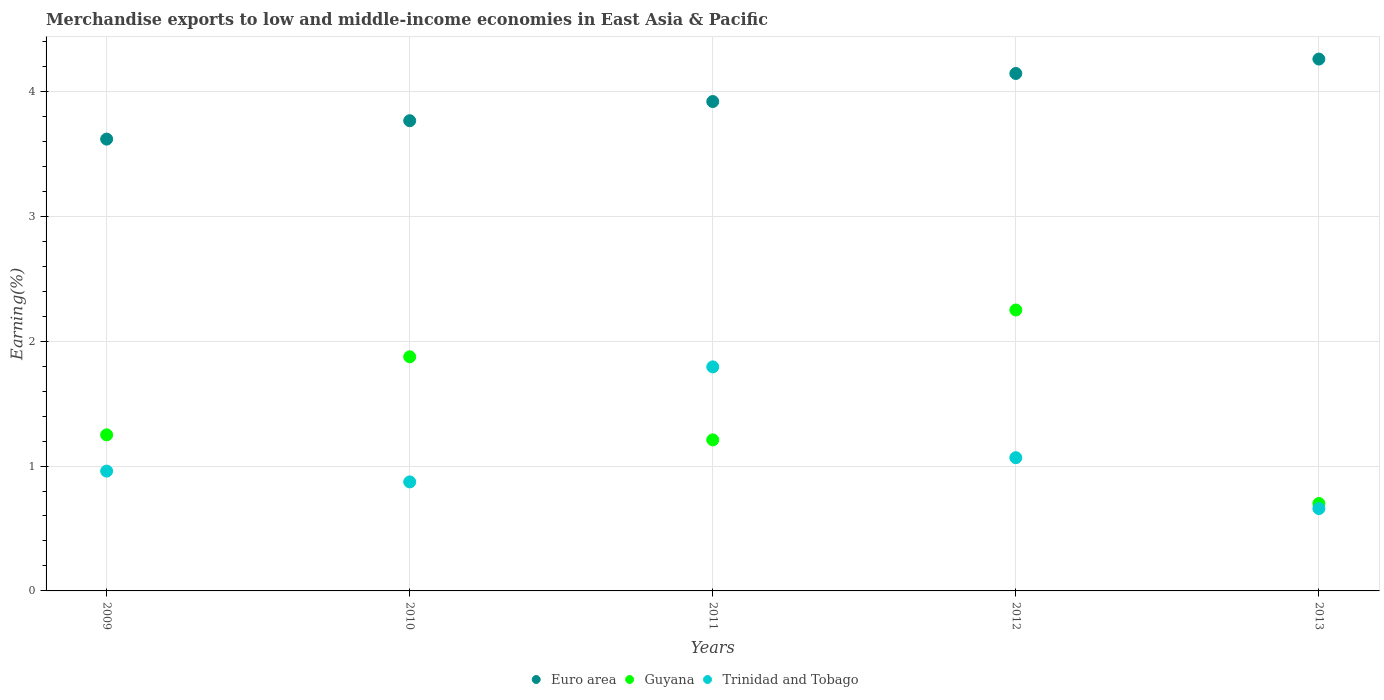Is the number of dotlines equal to the number of legend labels?
Your answer should be very brief. Yes. What is the percentage of amount earned from merchandise exports in Trinidad and Tobago in 2013?
Ensure brevity in your answer.  0.66. Across all years, what is the maximum percentage of amount earned from merchandise exports in Trinidad and Tobago?
Make the answer very short. 1.79. Across all years, what is the minimum percentage of amount earned from merchandise exports in Guyana?
Give a very brief answer. 0.7. What is the total percentage of amount earned from merchandise exports in Trinidad and Tobago in the graph?
Your answer should be compact. 5.35. What is the difference between the percentage of amount earned from merchandise exports in Trinidad and Tobago in 2011 and that in 2013?
Your answer should be compact. 1.13. What is the difference between the percentage of amount earned from merchandise exports in Trinidad and Tobago in 2013 and the percentage of amount earned from merchandise exports in Euro area in 2010?
Provide a succinct answer. -3.11. What is the average percentage of amount earned from merchandise exports in Guyana per year?
Your response must be concise. 1.46. In the year 2013, what is the difference between the percentage of amount earned from merchandise exports in Euro area and percentage of amount earned from merchandise exports in Guyana?
Provide a short and direct response. 3.56. What is the ratio of the percentage of amount earned from merchandise exports in Trinidad and Tobago in 2012 to that in 2013?
Provide a short and direct response. 1.62. Is the difference between the percentage of amount earned from merchandise exports in Euro area in 2009 and 2012 greater than the difference between the percentage of amount earned from merchandise exports in Guyana in 2009 and 2012?
Provide a succinct answer. Yes. What is the difference between the highest and the second highest percentage of amount earned from merchandise exports in Guyana?
Keep it short and to the point. 0.37. What is the difference between the highest and the lowest percentage of amount earned from merchandise exports in Guyana?
Offer a terse response. 1.55. In how many years, is the percentage of amount earned from merchandise exports in Trinidad and Tobago greater than the average percentage of amount earned from merchandise exports in Trinidad and Tobago taken over all years?
Keep it short and to the point. 1. Is it the case that in every year, the sum of the percentage of amount earned from merchandise exports in Trinidad and Tobago and percentage of amount earned from merchandise exports in Guyana  is greater than the percentage of amount earned from merchandise exports in Euro area?
Provide a succinct answer. No. Is the percentage of amount earned from merchandise exports in Trinidad and Tobago strictly greater than the percentage of amount earned from merchandise exports in Guyana over the years?
Provide a succinct answer. No. How many years are there in the graph?
Offer a very short reply. 5. What is the difference between two consecutive major ticks on the Y-axis?
Offer a very short reply. 1. Does the graph contain any zero values?
Your answer should be compact. No. Does the graph contain grids?
Provide a short and direct response. Yes. What is the title of the graph?
Your answer should be compact. Merchandise exports to low and middle-income economies in East Asia & Pacific. What is the label or title of the X-axis?
Your answer should be very brief. Years. What is the label or title of the Y-axis?
Keep it short and to the point. Earning(%). What is the Earning(%) of Euro area in 2009?
Give a very brief answer. 3.62. What is the Earning(%) in Guyana in 2009?
Keep it short and to the point. 1.25. What is the Earning(%) of Trinidad and Tobago in 2009?
Provide a short and direct response. 0.96. What is the Earning(%) of Euro area in 2010?
Give a very brief answer. 3.76. What is the Earning(%) in Guyana in 2010?
Provide a short and direct response. 1.87. What is the Earning(%) in Trinidad and Tobago in 2010?
Offer a very short reply. 0.87. What is the Earning(%) in Euro area in 2011?
Offer a terse response. 3.92. What is the Earning(%) of Guyana in 2011?
Keep it short and to the point. 1.21. What is the Earning(%) of Trinidad and Tobago in 2011?
Offer a terse response. 1.79. What is the Earning(%) in Euro area in 2012?
Offer a very short reply. 4.14. What is the Earning(%) of Guyana in 2012?
Keep it short and to the point. 2.25. What is the Earning(%) of Trinidad and Tobago in 2012?
Give a very brief answer. 1.07. What is the Earning(%) of Euro area in 2013?
Make the answer very short. 4.26. What is the Earning(%) of Guyana in 2013?
Your response must be concise. 0.7. What is the Earning(%) of Trinidad and Tobago in 2013?
Your answer should be compact. 0.66. Across all years, what is the maximum Earning(%) of Euro area?
Your answer should be very brief. 4.26. Across all years, what is the maximum Earning(%) in Guyana?
Ensure brevity in your answer.  2.25. Across all years, what is the maximum Earning(%) in Trinidad and Tobago?
Provide a short and direct response. 1.79. Across all years, what is the minimum Earning(%) of Euro area?
Provide a succinct answer. 3.62. Across all years, what is the minimum Earning(%) in Guyana?
Provide a succinct answer. 0.7. Across all years, what is the minimum Earning(%) of Trinidad and Tobago?
Provide a succinct answer. 0.66. What is the total Earning(%) of Euro area in the graph?
Offer a terse response. 19.7. What is the total Earning(%) in Guyana in the graph?
Ensure brevity in your answer.  7.28. What is the total Earning(%) of Trinidad and Tobago in the graph?
Your response must be concise. 5.35. What is the difference between the Earning(%) of Euro area in 2009 and that in 2010?
Offer a very short reply. -0.15. What is the difference between the Earning(%) of Guyana in 2009 and that in 2010?
Your response must be concise. -0.62. What is the difference between the Earning(%) in Trinidad and Tobago in 2009 and that in 2010?
Give a very brief answer. 0.09. What is the difference between the Earning(%) of Euro area in 2009 and that in 2011?
Provide a short and direct response. -0.3. What is the difference between the Earning(%) in Guyana in 2009 and that in 2011?
Make the answer very short. 0.04. What is the difference between the Earning(%) in Trinidad and Tobago in 2009 and that in 2011?
Provide a succinct answer. -0.83. What is the difference between the Earning(%) of Euro area in 2009 and that in 2012?
Your response must be concise. -0.53. What is the difference between the Earning(%) in Guyana in 2009 and that in 2012?
Keep it short and to the point. -1. What is the difference between the Earning(%) in Trinidad and Tobago in 2009 and that in 2012?
Keep it short and to the point. -0.11. What is the difference between the Earning(%) in Euro area in 2009 and that in 2013?
Make the answer very short. -0.64. What is the difference between the Earning(%) in Guyana in 2009 and that in 2013?
Give a very brief answer. 0.55. What is the difference between the Earning(%) in Euro area in 2010 and that in 2011?
Ensure brevity in your answer.  -0.15. What is the difference between the Earning(%) in Guyana in 2010 and that in 2011?
Offer a terse response. 0.67. What is the difference between the Earning(%) in Trinidad and Tobago in 2010 and that in 2011?
Provide a succinct answer. -0.92. What is the difference between the Earning(%) in Euro area in 2010 and that in 2012?
Offer a terse response. -0.38. What is the difference between the Earning(%) of Guyana in 2010 and that in 2012?
Keep it short and to the point. -0.37. What is the difference between the Earning(%) of Trinidad and Tobago in 2010 and that in 2012?
Provide a short and direct response. -0.19. What is the difference between the Earning(%) in Euro area in 2010 and that in 2013?
Your response must be concise. -0.49. What is the difference between the Earning(%) of Guyana in 2010 and that in 2013?
Ensure brevity in your answer.  1.17. What is the difference between the Earning(%) in Trinidad and Tobago in 2010 and that in 2013?
Your response must be concise. 0.21. What is the difference between the Earning(%) of Euro area in 2011 and that in 2012?
Your response must be concise. -0.22. What is the difference between the Earning(%) in Guyana in 2011 and that in 2012?
Ensure brevity in your answer.  -1.04. What is the difference between the Earning(%) of Trinidad and Tobago in 2011 and that in 2012?
Ensure brevity in your answer.  0.73. What is the difference between the Earning(%) of Euro area in 2011 and that in 2013?
Your answer should be very brief. -0.34. What is the difference between the Earning(%) of Guyana in 2011 and that in 2013?
Provide a short and direct response. 0.51. What is the difference between the Earning(%) in Trinidad and Tobago in 2011 and that in 2013?
Your answer should be very brief. 1.13. What is the difference between the Earning(%) of Euro area in 2012 and that in 2013?
Give a very brief answer. -0.12. What is the difference between the Earning(%) of Guyana in 2012 and that in 2013?
Provide a short and direct response. 1.55. What is the difference between the Earning(%) of Trinidad and Tobago in 2012 and that in 2013?
Ensure brevity in your answer.  0.41. What is the difference between the Earning(%) of Euro area in 2009 and the Earning(%) of Guyana in 2010?
Your response must be concise. 1.74. What is the difference between the Earning(%) of Euro area in 2009 and the Earning(%) of Trinidad and Tobago in 2010?
Offer a very short reply. 2.75. What is the difference between the Earning(%) in Guyana in 2009 and the Earning(%) in Trinidad and Tobago in 2010?
Keep it short and to the point. 0.38. What is the difference between the Earning(%) in Euro area in 2009 and the Earning(%) in Guyana in 2011?
Provide a succinct answer. 2.41. What is the difference between the Earning(%) of Euro area in 2009 and the Earning(%) of Trinidad and Tobago in 2011?
Provide a short and direct response. 1.82. What is the difference between the Earning(%) in Guyana in 2009 and the Earning(%) in Trinidad and Tobago in 2011?
Provide a succinct answer. -0.54. What is the difference between the Earning(%) of Euro area in 2009 and the Earning(%) of Guyana in 2012?
Your answer should be compact. 1.37. What is the difference between the Earning(%) in Euro area in 2009 and the Earning(%) in Trinidad and Tobago in 2012?
Give a very brief answer. 2.55. What is the difference between the Earning(%) of Guyana in 2009 and the Earning(%) of Trinidad and Tobago in 2012?
Your response must be concise. 0.18. What is the difference between the Earning(%) in Euro area in 2009 and the Earning(%) in Guyana in 2013?
Make the answer very short. 2.92. What is the difference between the Earning(%) in Euro area in 2009 and the Earning(%) in Trinidad and Tobago in 2013?
Ensure brevity in your answer.  2.96. What is the difference between the Earning(%) of Guyana in 2009 and the Earning(%) of Trinidad and Tobago in 2013?
Provide a succinct answer. 0.59. What is the difference between the Earning(%) of Euro area in 2010 and the Earning(%) of Guyana in 2011?
Your answer should be very brief. 2.56. What is the difference between the Earning(%) of Euro area in 2010 and the Earning(%) of Trinidad and Tobago in 2011?
Your response must be concise. 1.97. What is the difference between the Earning(%) of Guyana in 2010 and the Earning(%) of Trinidad and Tobago in 2011?
Give a very brief answer. 0.08. What is the difference between the Earning(%) of Euro area in 2010 and the Earning(%) of Guyana in 2012?
Your answer should be compact. 1.52. What is the difference between the Earning(%) of Euro area in 2010 and the Earning(%) of Trinidad and Tobago in 2012?
Keep it short and to the point. 2.7. What is the difference between the Earning(%) of Guyana in 2010 and the Earning(%) of Trinidad and Tobago in 2012?
Offer a very short reply. 0.81. What is the difference between the Earning(%) of Euro area in 2010 and the Earning(%) of Guyana in 2013?
Provide a short and direct response. 3.06. What is the difference between the Earning(%) in Euro area in 2010 and the Earning(%) in Trinidad and Tobago in 2013?
Provide a succinct answer. 3.11. What is the difference between the Earning(%) of Guyana in 2010 and the Earning(%) of Trinidad and Tobago in 2013?
Give a very brief answer. 1.22. What is the difference between the Earning(%) in Euro area in 2011 and the Earning(%) in Guyana in 2012?
Make the answer very short. 1.67. What is the difference between the Earning(%) in Euro area in 2011 and the Earning(%) in Trinidad and Tobago in 2012?
Ensure brevity in your answer.  2.85. What is the difference between the Earning(%) of Guyana in 2011 and the Earning(%) of Trinidad and Tobago in 2012?
Your response must be concise. 0.14. What is the difference between the Earning(%) of Euro area in 2011 and the Earning(%) of Guyana in 2013?
Make the answer very short. 3.22. What is the difference between the Earning(%) of Euro area in 2011 and the Earning(%) of Trinidad and Tobago in 2013?
Provide a succinct answer. 3.26. What is the difference between the Earning(%) in Guyana in 2011 and the Earning(%) in Trinidad and Tobago in 2013?
Offer a terse response. 0.55. What is the difference between the Earning(%) in Euro area in 2012 and the Earning(%) in Guyana in 2013?
Make the answer very short. 3.44. What is the difference between the Earning(%) in Euro area in 2012 and the Earning(%) in Trinidad and Tobago in 2013?
Keep it short and to the point. 3.48. What is the difference between the Earning(%) of Guyana in 2012 and the Earning(%) of Trinidad and Tobago in 2013?
Give a very brief answer. 1.59. What is the average Earning(%) in Euro area per year?
Your answer should be compact. 3.94. What is the average Earning(%) of Guyana per year?
Ensure brevity in your answer.  1.46. What is the average Earning(%) in Trinidad and Tobago per year?
Make the answer very short. 1.07. In the year 2009, what is the difference between the Earning(%) in Euro area and Earning(%) in Guyana?
Your response must be concise. 2.37. In the year 2009, what is the difference between the Earning(%) in Euro area and Earning(%) in Trinidad and Tobago?
Your answer should be very brief. 2.66. In the year 2009, what is the difference between the Earning(%) of Guyana and Earning(%) of Trinidad and Tobago?
Your answer should be compact. 0.29. In the year 2010, what is the difference between the Earning(%) in Euro area and Earning(%) in Guyana?
Your answer should be very brief. 1.89. In the year 2010, what is the difference between the Earning(%) of Euro area and Earning(%) of Trinidad and Tobago?
Provide a succinct answer. 2.89. In the year 2011, what is the difference between the Earning(%) in Euro area and Earning(%) in Guyana?
Make the answer very short. 2.71. In the year 2011, what is the difference between the Earning(%) in Euro area and Earning(%) in Trinidad and Tobago?
Keep it short and to the point. 2.12. In the year 2011, what is the difference between the Earning(%) in Guyana and Earning(%) in Trinidad and Tobago?
Your answer should be compact. -0.58. In the year 2012, what is the difference between the Earning(%) of Euro area and Earning(%) of Guyana?
Offer a very short reply. 1.89. In the year 2012, what is the difference between the Earning(%) in Euro area and Earning(%) in Trinidad and Tobago?
Offer a terse response. 3.08. In the year 2012, what is the difference between the Earning(%) of Guyana and Earning(%) of Trinidad and Tobago?
Give a very brief answer. 1.18. In the year 2013, what is the difference between the Earning(%) of Euro area and Earning(%) of Guyana?
Keep it short and to the point. 3.56. In the year 2013, what is the difference between the Earning(%) in Euro area and Earning(%) in Trinidad and Tobago?
Offer a terse response. 3.6. In the year 2013, what is the difference between the Earning(%) of Guyana and Earning(%) of Trinidad and Tobago?
Ensure brevity in your answer.  0.04. What is the ratio of the Earning(%) in Euro area in 2009 to that in 2010?
Your answer should be compact. 0.96. What is the ratio of the Earning(%) in Guyana in 2009 to that in 2010?
Your response must be concise. 0.67. What is the ratio of the Earning(%) in Trinidad and Tobago in 2009 to that in 2010?
Offer a terse response. 1.1. What is the ratio of the Earning(%) in Euro area in 2009 to that in 2011?
Provide a succinct answer. 0.92. What is the ratio of the Earning(%) in Guyana in 2009 to that in 2011?
Provide a succinct answer. 1.03. What is the ratio of the Earning(%) in Trinidad and Tobago in 2009 to that in 2011?
Provide a succinct answer. 0.53. What is the ratio of the Earning(%) of Euro area in 2009 to that in 2012?
Make the answer very short. 0.87. What is the ratio of the Earning(%) of Guyana in 2009 to that in 2012?
Offer a very short reply. 0.56. What is the ratio of the Earning(%) of Trinidad and Tobago in 2009 to that in 2012?
Provide a succinct answer. 0.9. What is the ratio of the Earning(%) in Euro area in 2009 to that in 2013?
Your response must be concise. 0.85. What is the ratio of the Earning(%) of Guyana in 2009 to that in 2013?
Ensure brevity in your answer.  1.79. What is the ratio of the Earning(%) of Trinidad and Tobago in 2009 to that in 2013?
Offer a very short reply. 1.46. What is the ratio of the Earning(%) of Euro area in 2010 to that in 2011?
Offer a terse response. 0.96. What is the ratio of the Earning(%) of Guyana in 2010 to that in 2011?
Offer a terse response. 1.55. What is the ratio of the Earning(%) of Trinidad and Tobago in 2010 to that in 2011?
Make the answer very short. 0.49. What is the ratio of the Earning(%) in Euro area in 2010 to that in 2012?
Provide a short and direct response. 0.91. What is the ratio of the Earning(%) in Guyana in 2010 to that in 2012?
Your response must be concise. 0.83. What is the ratio of the Earning(%) in Trinidad and Tobago in 2010 to that in 2012?
Your answer should be very brief. 0.82. What is the ratio of the Earning(%) in Euro area in 2010 to that in 2013?
Provide a succinct answer. 0.88. What is the ratio of the Earning(%) in Guyana in 2010 to that in 2013?
Offer a very short reply. 2.68. What is the ratio of the Earning(%) in Trinidad and Tobago in 2010 to that in 2013?
Ensure brevity in your answer.  1.32. What is the ratio of the Earning(%) in Euro area in 2011 to that in 2012?
Keep it short and to the point. 0.95. What is the ratio of the Earning(%) of Guyana in 2011 to that in 2012?
Offer a very short reply. 0.54. What is the ratio of the Earning(%) of Trinidad and Tobago in 2011 to that in 2012?
Offer a terse response. 1.68. What is the ratio of the Earning(%) in Euro area in 2011 to that in 2013?
Your answer should be compact. 0.92. What is the ratio of the Earning(%) in Guyana in 2011 to that in 2013?
Provide a short and direct response. 1.73. What is the ratio of the Earning(%) of Trinidad and Tobago in 2011 to that in 2013?
Your response must be concise. 2.72. What is the ratio of the Earning(%) of Euro area in 2012 to that in 2013?
Give a very brief answer. 0.97. What is the ratio of the Earning(%) in Guyana in 2012 to that in 2013?
Offer a very short reply. 3.21. What is the ratio of the Earning(%) in Trinidad and Tobago in 2012 to that in 2013?
Ensure brevity in your answer.  1.62. What is the difference between the highest and the second highest Earning(%) of Euro area?
Make the answer very short. 0.12. What is the difference between the highest and the second highest Earning(%) of Guyana?
Your response must be concise. 0.37. What is the difference between the highest and the second highest Earning(%) of Trinidad and Tobago?
Provide a short and direct response. 0.73. What is the difference between the highest and the lowest Earning(%) in Euro area?
Keep it short and to the point. 0.64. What is the difference between the highest and the lowest Earning(%) of Guyana?
Keep it short and to the point. 1.55. What is the difference between the highest and the lowest Earning(%) of Trinidad and Tobago?
Offer a very short reply. 1.13. 